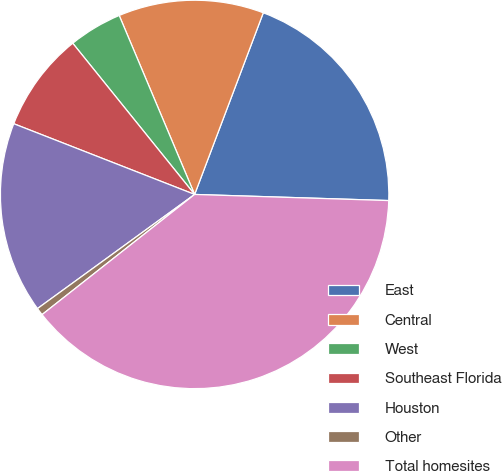Convert chart to OTSL. <chart><loc_0><loc_0><loc_500><loc_500><pie_chart><fcel>East<fcel>Central<fcel>West<fcel>Southeast Florida<fcel>Houston<fcel>Other<fcel>Total homesites<nl><fcel>19.75%<fcel>12.1%<fcel>4.45%<fcel>8.27%<fcel>15.93%<fcel>0.62%<fcel>38.88%<nl></chart> 